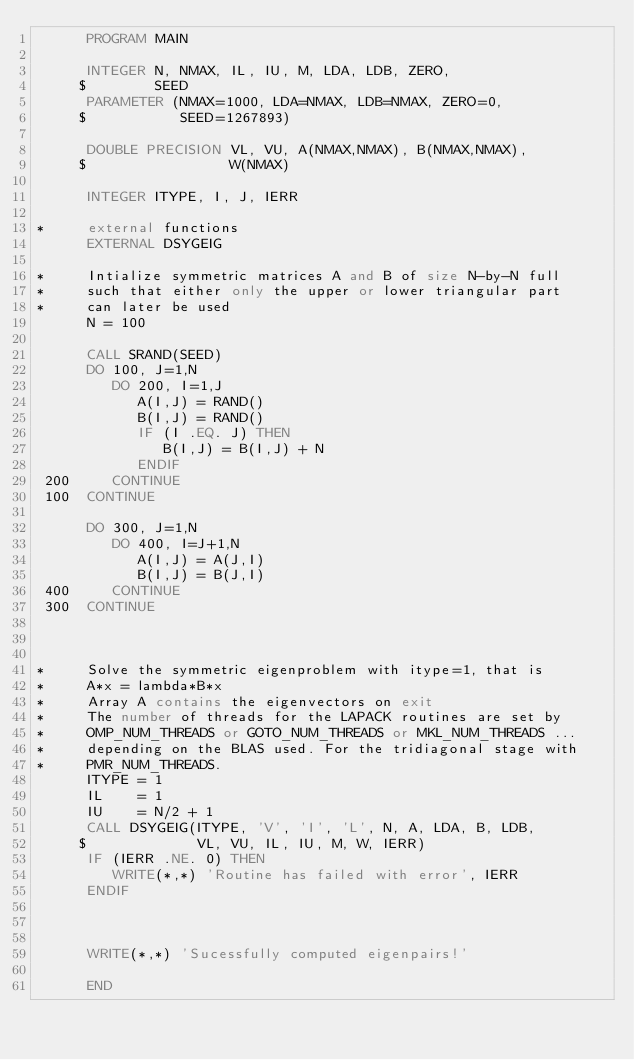Convert code to text. <code><loc_0><loc_0><loc_500><loc_500><_FORTRAN_>      PROGRAM MAIN

      INTEGER N, NMAX, IL, IU, M, LDA, LDB, ZERO,
     $        SEED
      PARAMETER (NMAX=1000, LDA=NMAX, LDB=NMAX, ZERO=0, 
     $           SEED=1267893)

      DOUBLE PRECISION VL, VU, A(NMAX,NMAX), B(NMAX,NMAX), 
     $                 W(NMAX)

      INTEGER ITYPE, I, J, IERR

*     external functions
      EXTERNAL DSYGEIG

*     Intialize symmetric matrices A and B of size N-by-N full
*     such that either only the upper or lower triangular part 
*     can later be used
      N = 100

      CALL SRAND(SEED)
      DO 100, J=1,N
         DO 200, I=1,J
            A(I,J) = RAND()
            B(I,J) = RAND()
            IF (I .EQ. J) THEN
               B(I,J) = B(I,J) + N
            ENDIF
 200     CONTINUE
 100  CONTINUE

      DO 300, J=1,N
         DO 400, I=J+1,N
            A(I,J) = A(J,I)
            B(I,J) = B(J,I)
 400     CONTINUE
 300  CONTINUE



*     Solve the symmetric eigenproblem with itype=1, that is 
*     A*x = lambda*B*x
*     Array A contains the eigenvectors on exit
*     The number of threads for the LAPACK routines are set by 
*     OMP_NUM_THREADS or GOTO_NUM_THREADS or MKL_NUM_THREADS ... 
*     depending on the BLAS used. For the tridiagonal stage with 
*     PMR_NUM_THREADS. 
      ITYPE = 1
      IL    = 1
      IU    = N/2 + 1
      CALL DSYGEIG(ITYPE, 'V', 'I', 'L', N, A, LDA, B, LDB,  
     $             VL, VU, IL, IU, M, W, IERR)
      IF (IERR .NE. 0) THEN
         WRITE(*,*) 'Routine has failed with error', IERR
      ENDIF



      WRITE(*,*) 'Sucessfully computed eigenpairs!'

      END
</code> 